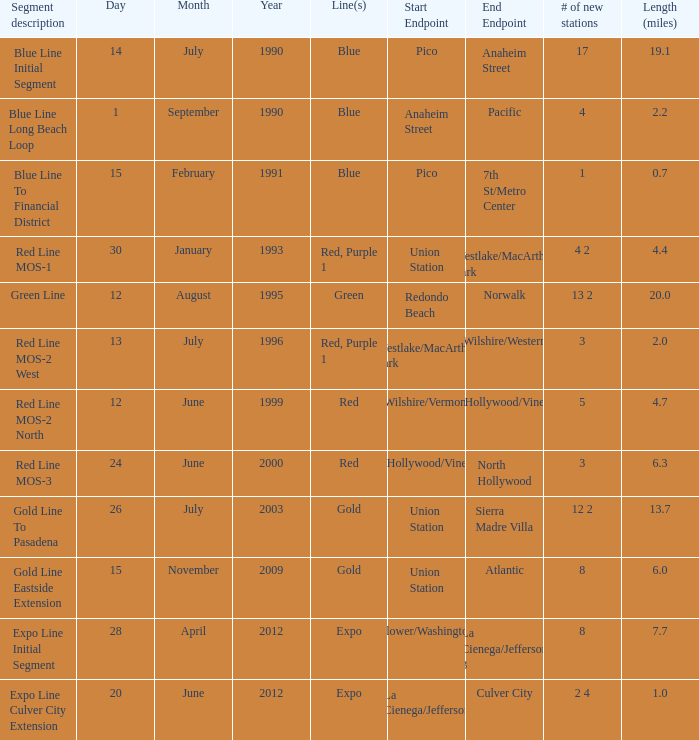What is the span (miles) when pico and 7th st/metro center are the terminals? 0.7. 